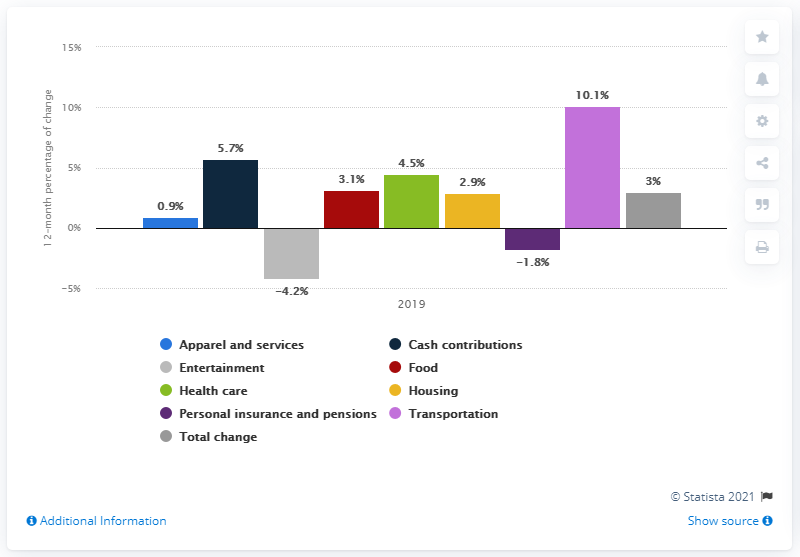Mention a couple of crucial points in this snapshot. The average annual expenditures for transportation increased by 10.1% in 2019 compared to 2018. 